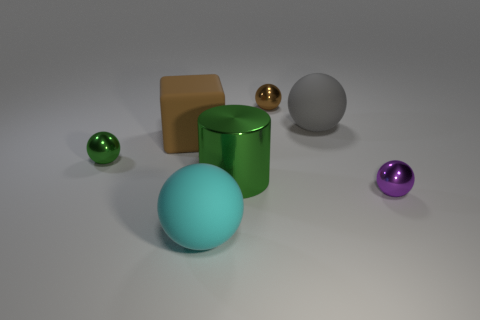Subtract all tiny green shiny balls. How many balls are left? 4 Subtract all yellow balls. Subtract all blue blocks. How many balls are left? 5 Add 1 large gray metal cylinders. How many objects exist? 8 Subtract all spheres. How many objects are left? 2 Subtract all large cyan things. Subtract all brown metallic balls. How many objects are left? 5 Add 2 big matte cubes. How many big matte cubes are left? 3 Add 2 yellow metallic things. How many yellow metallic things exist? 2 Subtract 0 gray blocks. How many objects are left? 7 